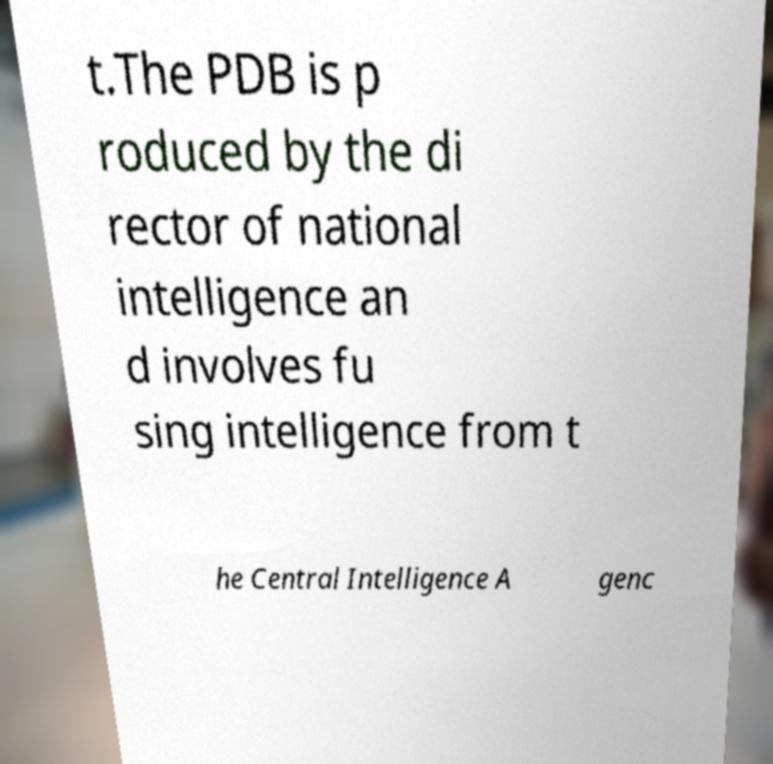For documentation purposes, I need the text within this image transcribed. Could you provide that? t.The PDB is p roduced by the di rector of national intelligence an d involves fu sing intelligence from t he Central Intelligence A genc 